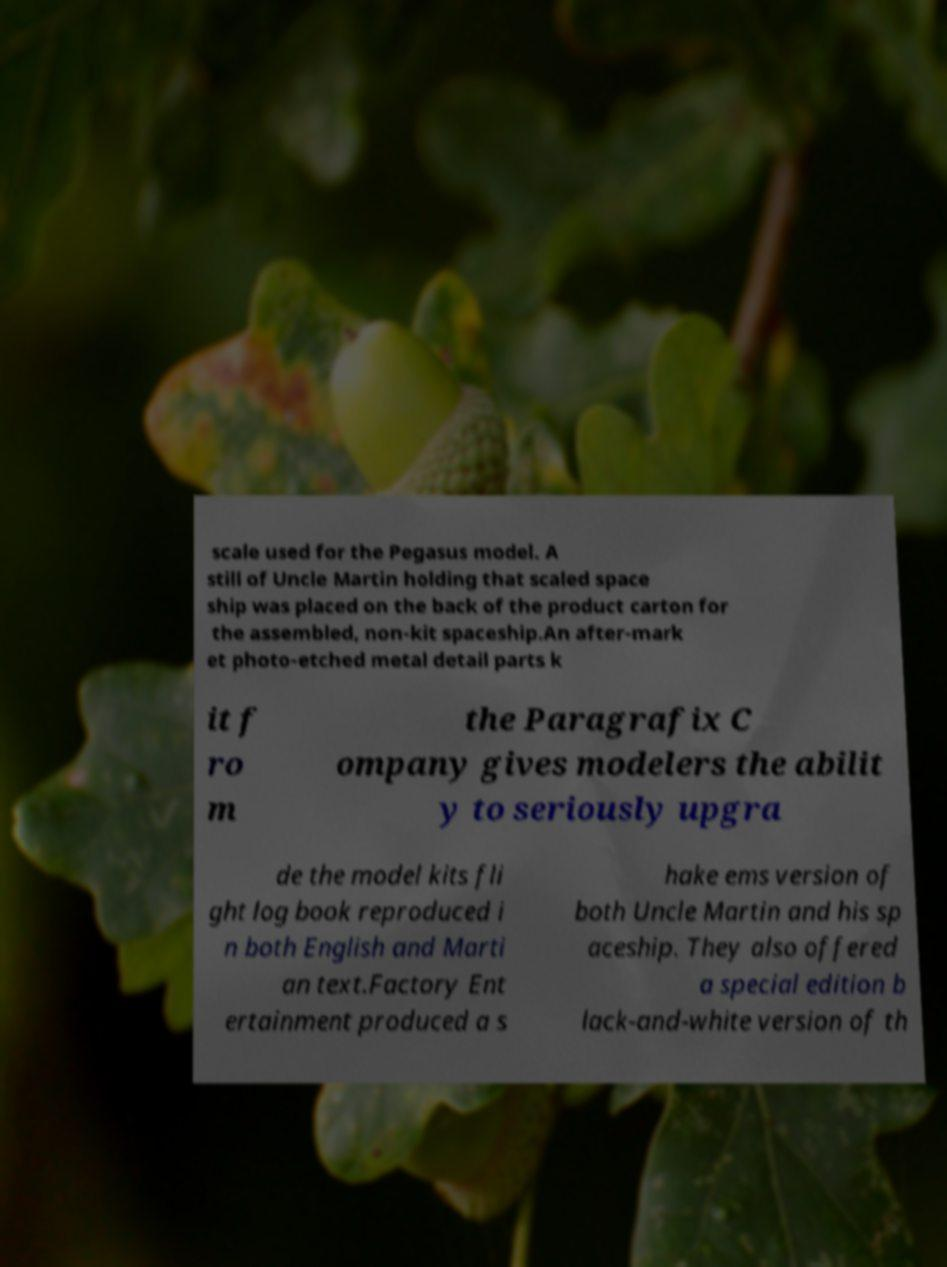Please identify and transcribe the text found in this image. scale used for the Pegasus model. A still of Uncle Martin holding that scaled space ship was placed on the back of the product carton for the assembled, non-kit spaceship.An after-mark et photo-etched metal detail parts k it f ro m the Paragrafix C ompany gives modelers the abilit y to seriously upgra de the model kits fli ght log book reproduced i n both English and Marti an text.Factory Ent ertainment produced a s hake ems version of both Uncle Martin and his sp aceship. They also offered a special edition b lack-and-white version of th 